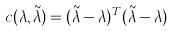Convert formula to latex. <formula><loc_0><loc_0><loc_500><loc_500>c ( \lambda , \tilde { \lambda } ) = ( \tilde { \lambda } - \lambda ) ^ { T } ( \tilde { \lambda } - \lambda )</formula> 